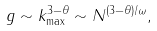<formula> <loc_0><loc_0><loc_500><loc_500>g \sim k _ { \max } ^ { 3 - \theta } \sim N ^ { ( 3 - \theta ) / \omega } ,</formula> 